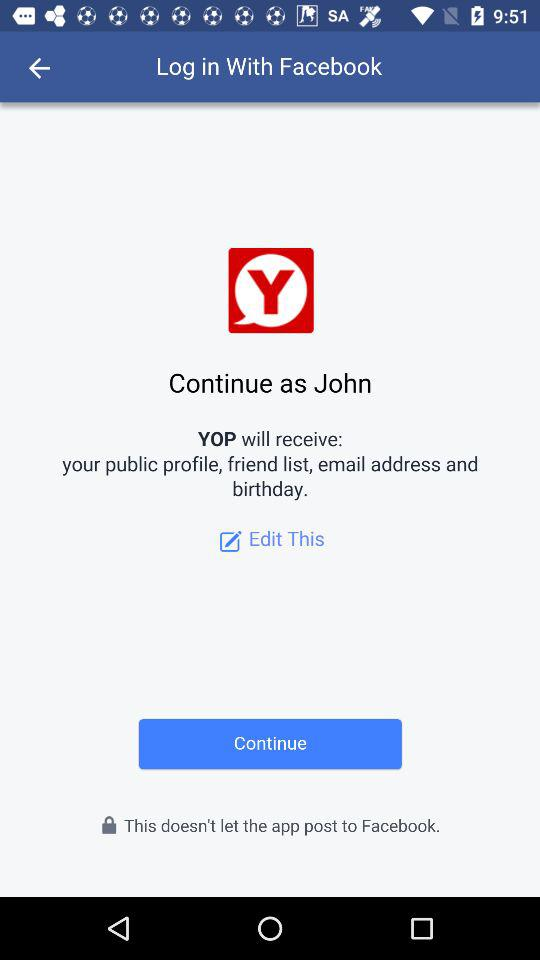What application will receive the public profile, friend list, email address and birthday? The application that will receive the public profile, friend list, email address and birthday is "YOP". 